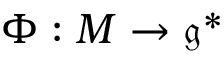Convert formula to latex. <formula><loc_0><loc_0><loc_500><loc_500>\Phi \colon M \to { \mathfrak { g } } ^ { * }</formula> 